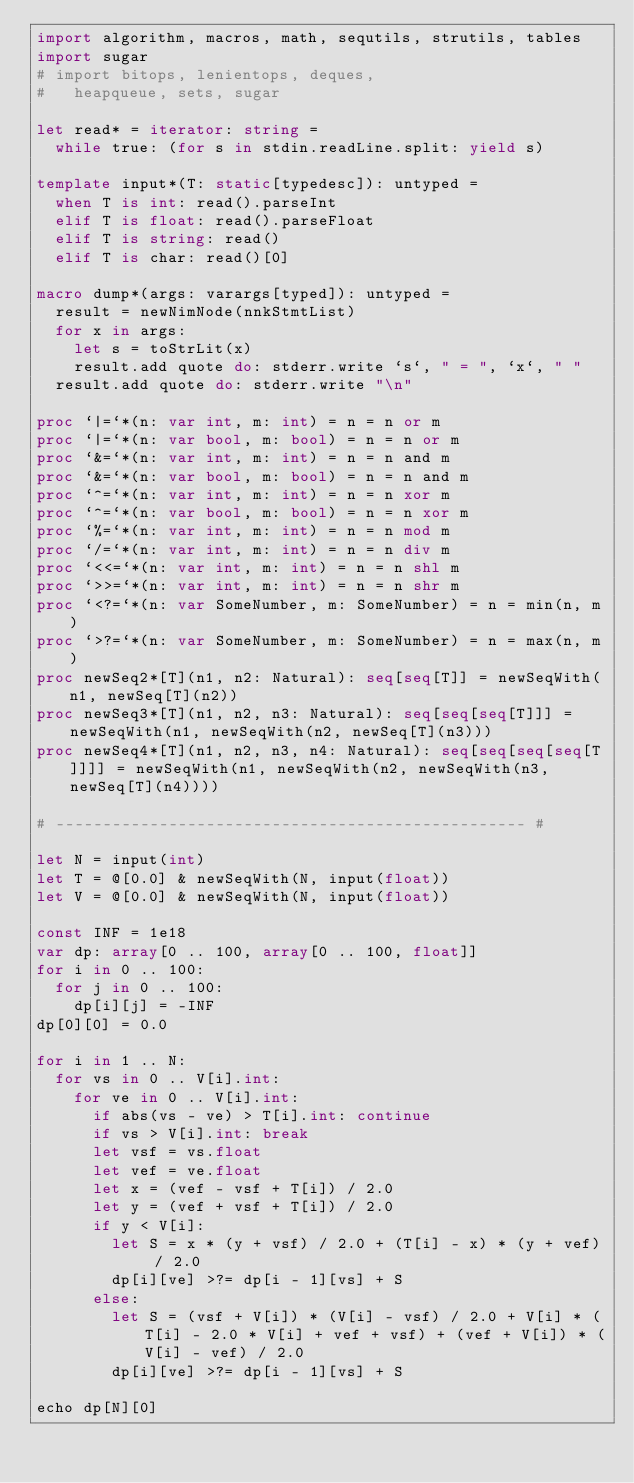Convert code to text. <code><loc_0><loc_0><loc_500><loc_500><_Nim_>import algorithm, macros, math, sequtils, strutils, tables
import sugar
# import bitops, lenientops, deques,
#   heapqueue, sets, sugar

let read* = iterator: string =
  while true: (for s in stdin.readLine.split: yield s)

template input*(T: static[typedesc]): untyped = 
  when T is int: read().parseInt
  elif T is float: read().parseFloat
  elif T is string: read()
  elif T is char: read()[0]

macro dump*(args: varargs[typed]): untyped =
  result = newNimNode(nnkStmtList)
  for x in args:
    let s = toStrLit(x)
    result.add quote do: stderr.write `s`, " = ", `x`, " "
  result.add quote do: stderr.write "\n"

proc `|=`*(n: var int, m: int) = n = n or m
proc `|=`*(n: var bool, m: bool) = n = n or m
proc `&=`*(n: var int, m: int) = n = n and m
proc `&=`*(n: var bool, m: bool) = n = n and m
proc `^=`*(n: var int, m: int) = n = n xor m
proc `^=`*(n: var bool, m: bool) = n = n xor m
proc `%=`*(n: var int, m: int) = n = n mod m
proc `/=`*(n: var int, m: int) = n = n div m
proc `<<=`*(n: var int, m: int) = n = n shl m
proc `>>=`*(n: var int, m: int) = n = n shr m
proc `<?=`*(n: var SomeNumber, m: SomeNumber) = n = min(n, m)
proc `>?=`*(n: var SomeNumber, m: SomeNumber) = n = max(n, m)
proc newSeq2*[T](n1, n2: Natural): seq[seq[T]] = newSeqWith(n1, newSeq[T](n2))
proc newSeq3*[T](n1, n2, n3: Natural): seq[seq[seq[T]]] = newSeqWith(n1, newSeqWith(n2, newSeq[T](n3)))
proc newSeq4*[T](n1, n2, n3, n4: Natural): seq[seq[seq[seq[T]]]] = newSeqWith(n1, newSeqWith(n2, newSeqWith(n3, newSeq[T](n4))))

# -------------------------------------------------- #

let N = input(int)
let T = @[0.0] & newSeqWith(N, input(float))
let V = @[0.0] & newSeqWith(N, input(float))

const INF = 1e18
var dp: array[0 .. 100, array[0 .. 100, float]]
for i in 0 .. 100:
  for j in 0 .. 100:
    dp[i][j] = -INF
dp[0][0] = 0.0

for i in 1 .. N:
  for vs in 0 .. V[i].int:
    for ve in 0 .. V[i].int:
      if abs(vs - ve) > T[i].int: continue
      if vs > V[i].int: break
      let vsf = vs.float
      let vef = ve.float
      let x = (vef - vsf + T[i]) / 2.0
      let y = (vef + vsf + T[i]) / 2.0
      if y < V[i]:
        let S = x * (y + vsf) / 2.0 + (T[i] - x) * (y + vef) / 2.0
        dp[i][ve] >?= dp[i - 1][vs] + S
      else:
        let S = (vsf + V[i]) * (V[i] - vsf) / 2.0 + V[i] * (T[i] - 2.0 * V[i] + vef + vsf) + (vef + V[i]) * (V[i] - vef) / 2.0
        dp[i][ve] >?= dp[i - 1][vs] + S

echo dp[N][0]
</code> 